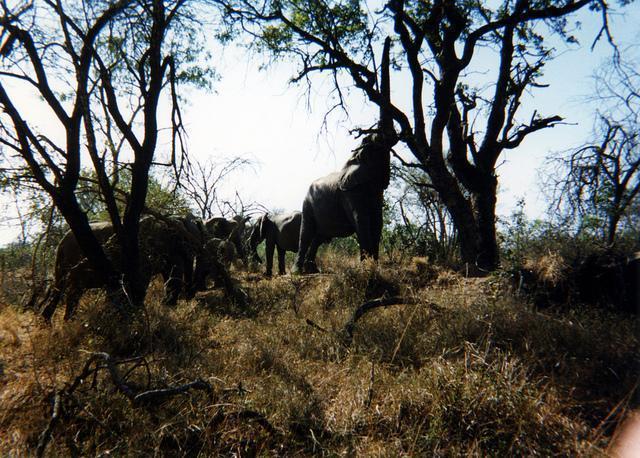In what setting are the animals?
Indicate the correct response and explain using: 'Answer: answer
Rationale: rationale.'
Options: Park, wilderness, zoo, farm. Answer: wilderness.
Rationale: They are in the wilderness. 